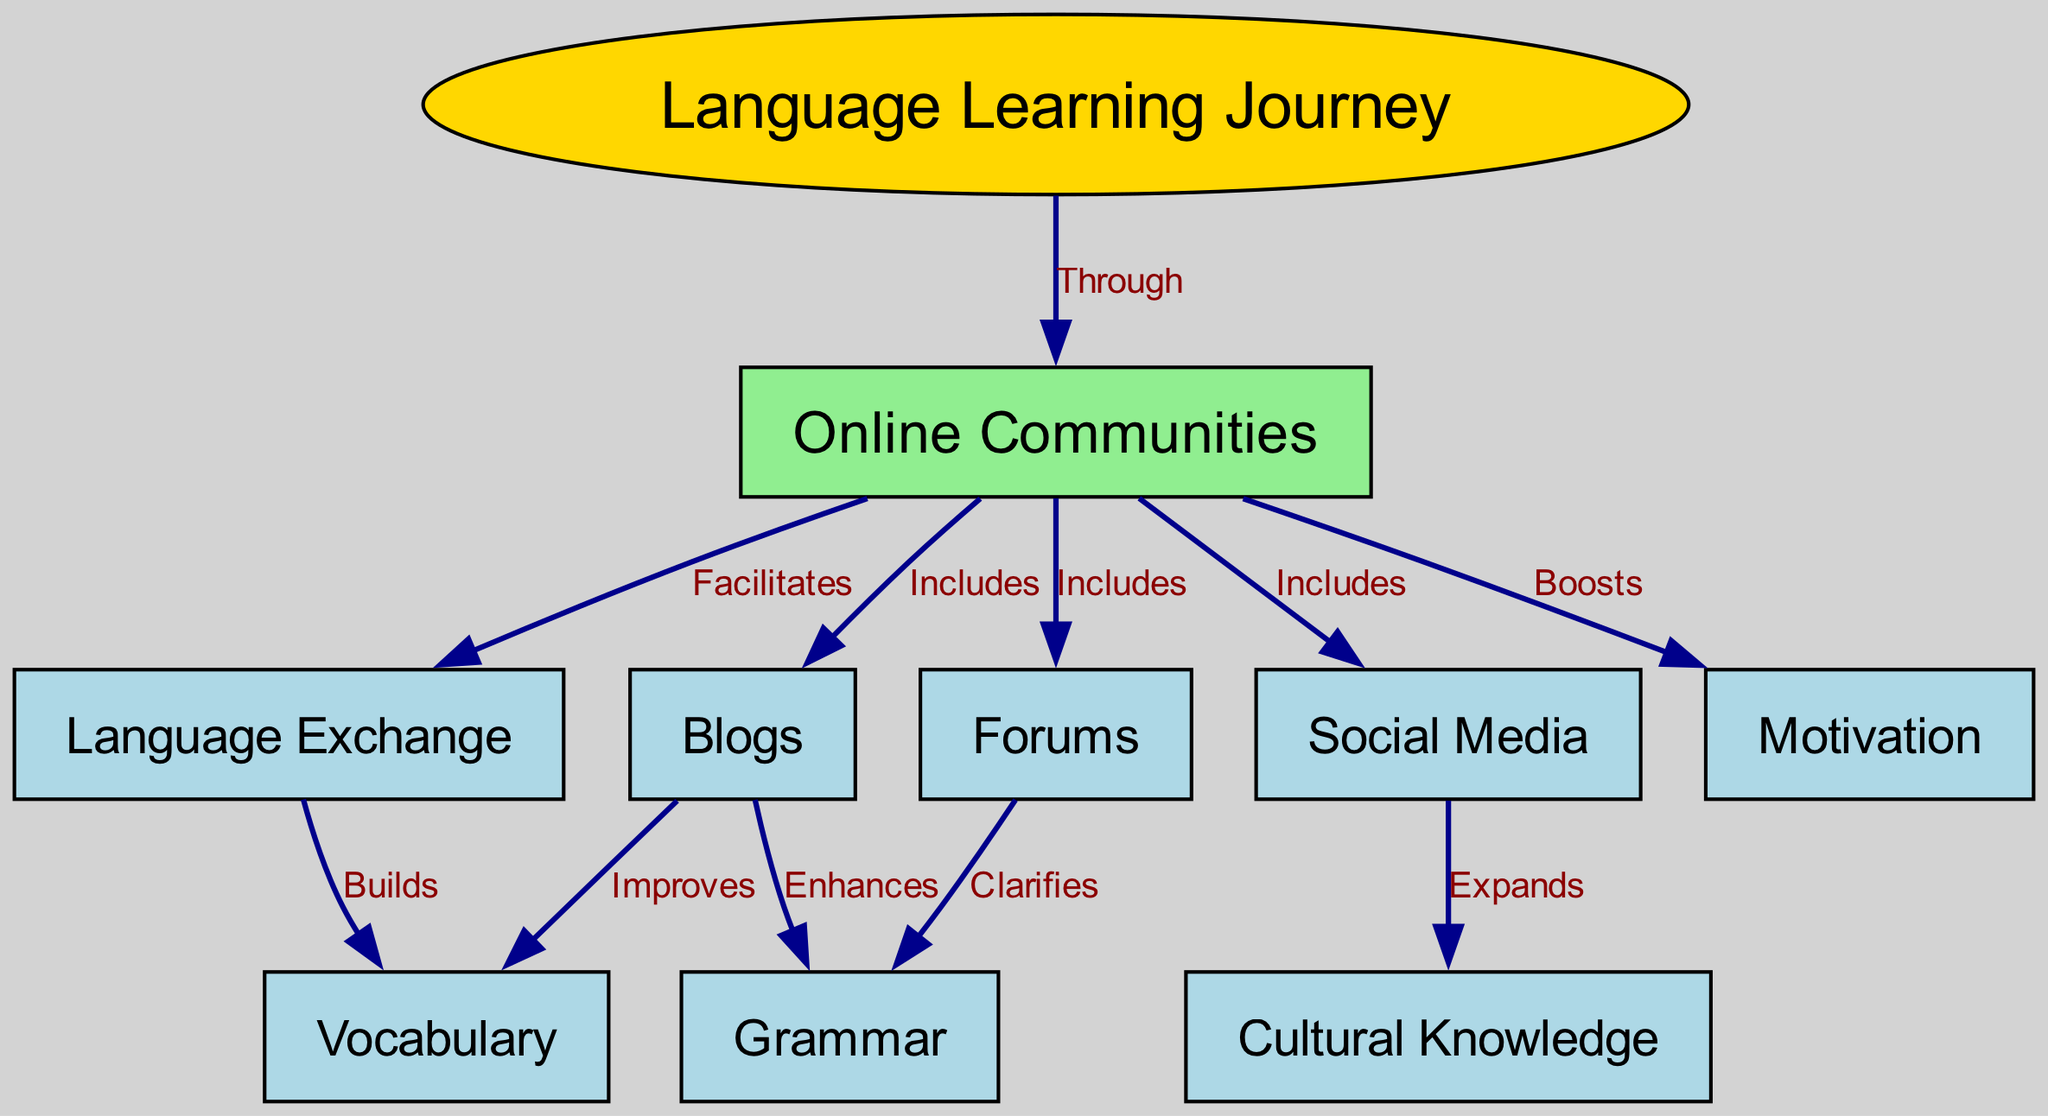What is the main topic of the diagram? The central node labeled "Language Learning Journey" defines the primary subject of the concept map. This node is the focal point around which other related concepts are organized.
Answer: Language Learning Journey How many nodes are in the diagram? By counting all unique nodes labeled in the concept map, we find there are ten distinct nodes connected to the central theme.
Answer: Ten Which node represents social platforms used for language learning? The node labeled "Social Media" indicates the type of online communities that facilitate language learning through sharing and interaction among users.
Answer: Social Media What type of knowledge does "Forums" primarily clarify? The edges connecting "Forums" and "Grammar" specifically denote that forums provide clarification regarding grammar rules and usage among language learners.
Answer: Grammar How does "Online Communities" impact motivation? The edge showing "Online Communities" leading to "Motivation" indicates that participation in these communities boosts learners' motivation through engagement and support from peers.
Answer: Boosts Which resource improves vocabulary according to the diagram? The connection between the node "Blogs" and "Vocabulary" indicates that blogs are a resource that significantly improves learners' vocabulary through diverse content.
Answer: Blogs What aspect of language learning does "Language Exchange" build? The linking of "Language Exchange" to "Vocabulary" reveals that engaging in language exchange helps in building vocabulary skills through practice and conversation with other learners.
Answer: Vocabulary What role does "Cultural Knowledge" play in connection with social media? The edge connecting "Social Media" to "Cultural Knowledge" suggests that social media platforms expand learners' understanding of different cultures, which is crucial while learning a new language.
Answer: Expands How many types of online communities are included? As indicated by the edges from "Online Communities," there are four types represented: Blogs, Social Media, Forums, and Language Exchange.
Answer: Four 